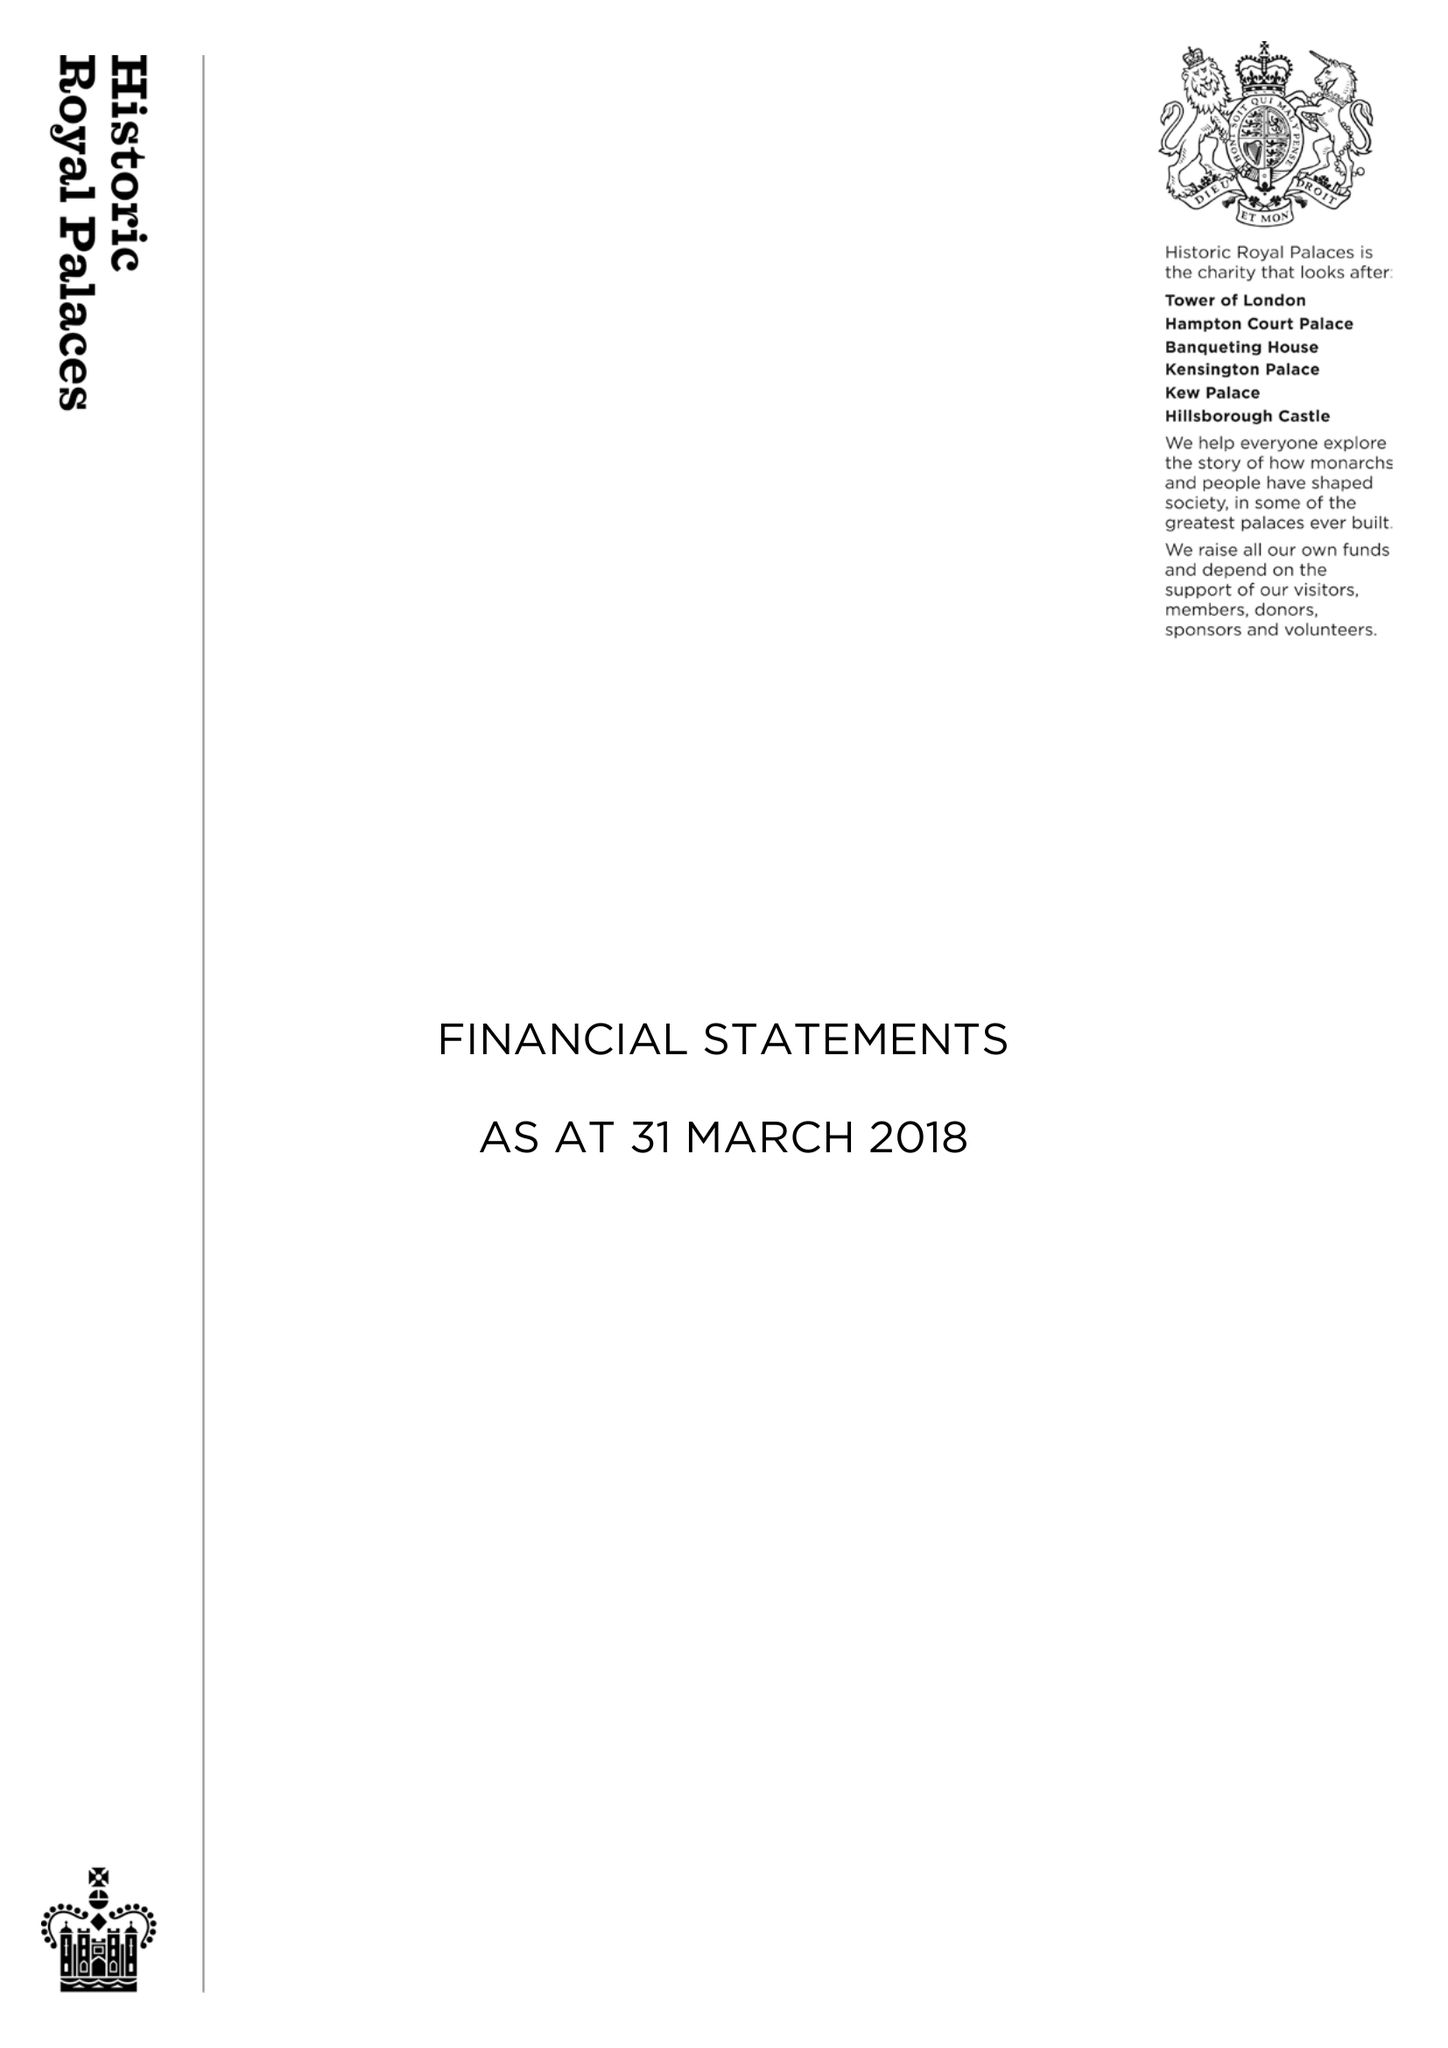What is the value for the address__street_line?
Answer the question using a single word or phrase. None 